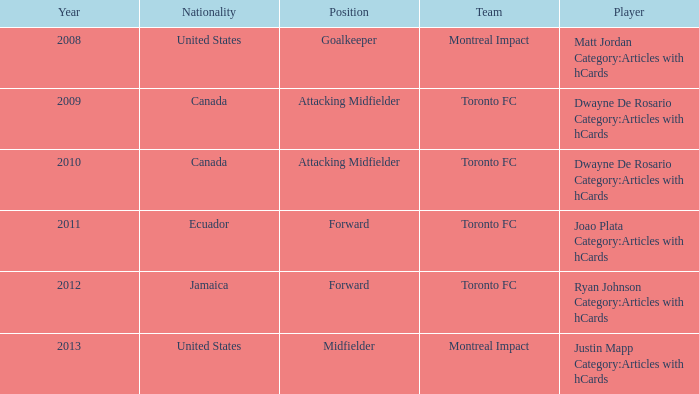After 2009, what's the nationality of a player named Dwayne de Rosario Category:articles with hcards? Canada. 